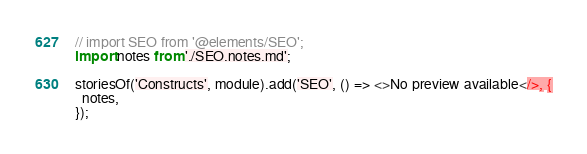Convert code to text. <code><loc_0><loc_0><loc_500><loc_500><_JavaScript_>// import SEO from '@elements/SEO';
import notes from './SEO.notes.md';

storiesOf('Constructs', module).add('SEO', () => <>No preview available</>, {
  notes,
});
</code> 